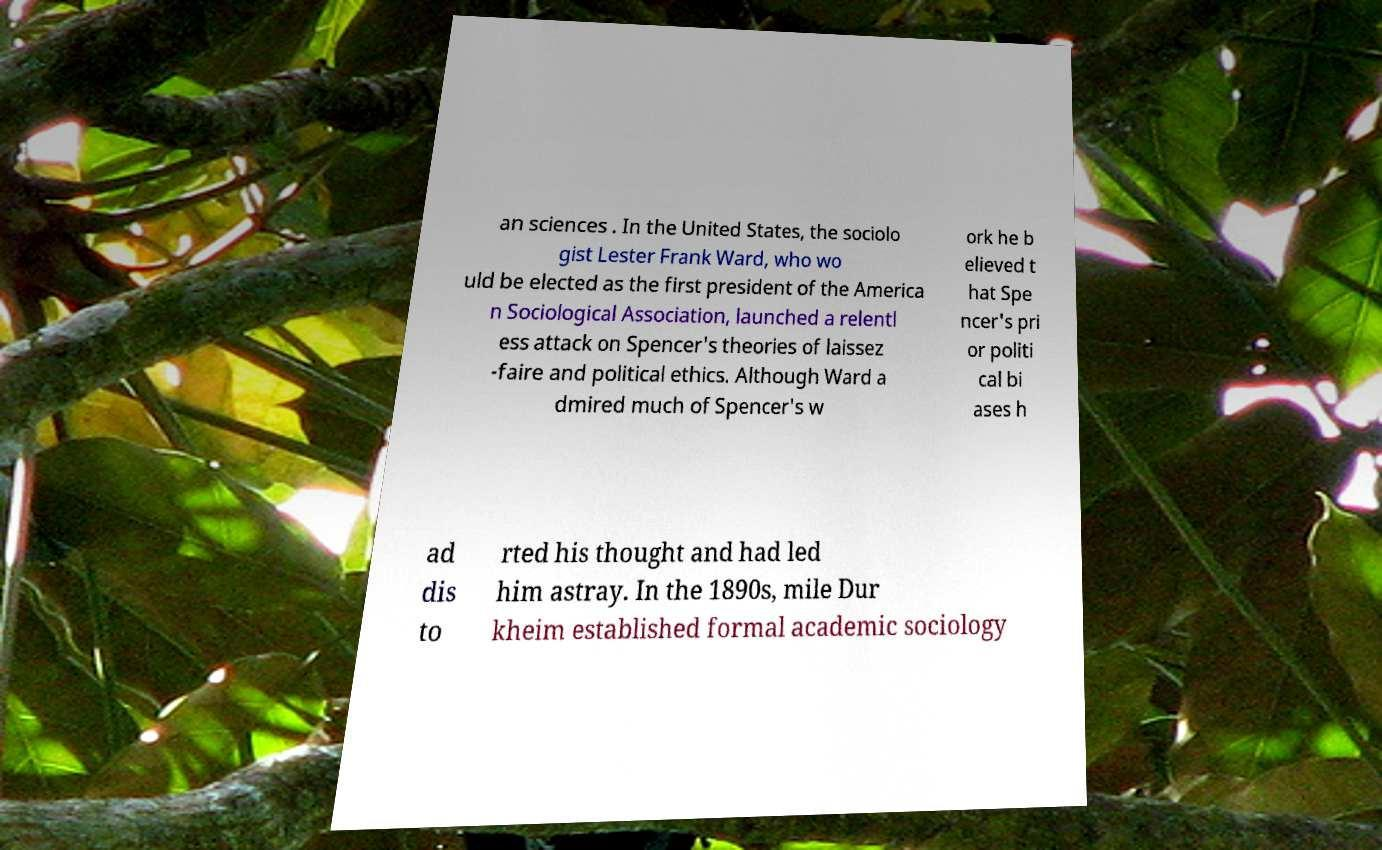There's text embedded in this image that I need extracted. Can you transcribe it verbatim? an sciences . In the United States, the sociolo gist Lester Frank Ward, who wo uld be elected as the first president of the America n Sociological Association, launched a relentl ess attack on Spencer's theories of laissez -faire and political ethics. Although Ward a dmired much of Spencer's w ork he b elieved t hat Spe ncer's pri or politi cal bi ases h ad dis to rted his thought and had led him astray. In the 1890s, mile Dur kheim established formal academic sociology 